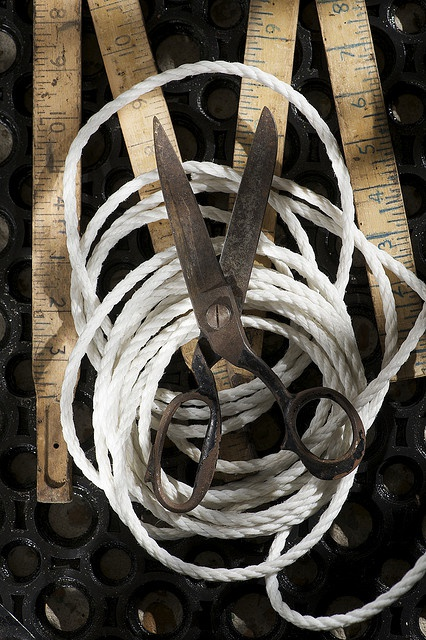Describe the objects in this image and their specific colors. I can see scissors in black and gray tones in this image. 